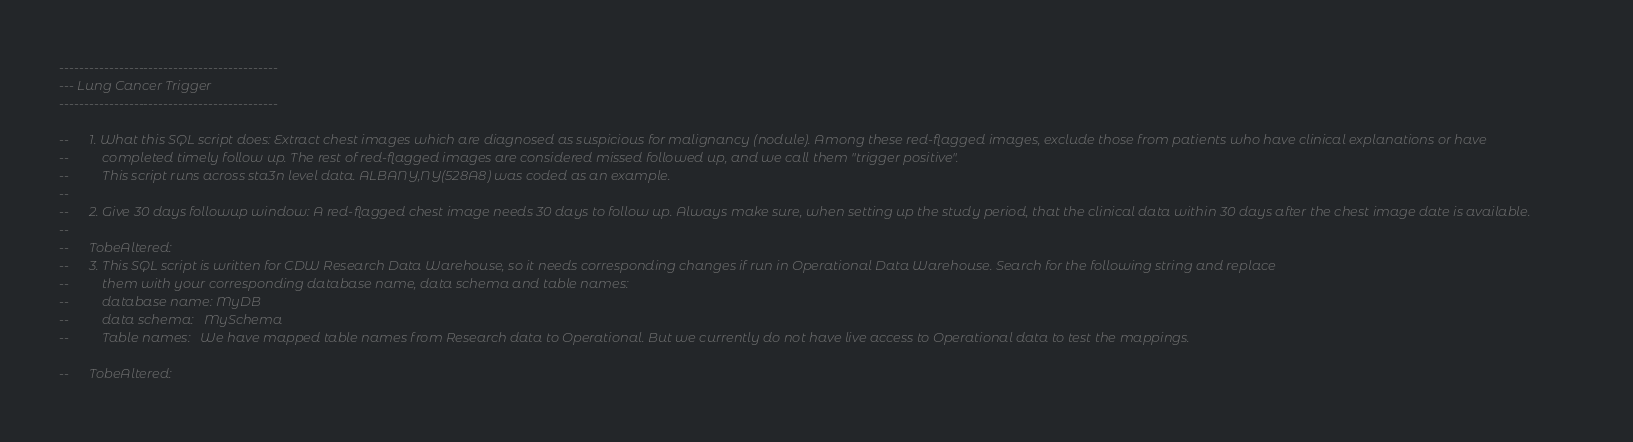Convert code to text. <code><loc_0><loc_0><loc_500><loc_500><_SQL_>--------------------------------------------
--- Lung Cancer Trigger 
--------------------------------------------

--		1. What this SQL script does: Extract chest images which are diagnosed as suspicious for malignancy (nodule). Among these red-flagged images, exclude those from patients who have clinical explanations or have 
--			completed timely follow up. The rest of red-flagged images are considered missed followed up, and we call them "trigger positive".
--          This script runs across sta3n level data. ALBANY,NY(528A8) was coded as an example.
--
--		2. Give 30 days followup window: A red-flagged chest image needs 30 days to follow up. Always make sure, when setting up the study period, that the clinical data within 30 days after the chest image date is available.
--
--      TobeAltered:
--		3. This SQL script is written for CDW Research Data Warehouse, so it needs corresponding changes if run in Operational Data Warehouse. Search for the following string and replace
--			them with your corresponding database name, data schema and table names:
--			database name: MyDB 
--			data schema:   MySchema 
--			Table names:   We have mapped table names from Research data to Operational. But we currently do not have live access to Operational data to test the mappings. 

--      TobeAltered:</code> 